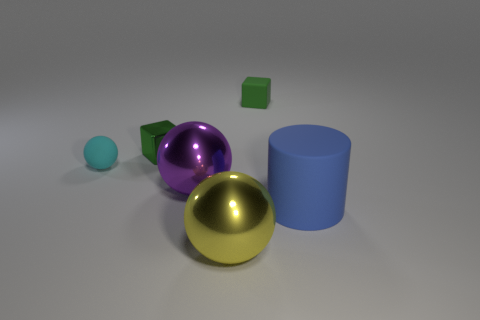Subtract all metal balls. How many balls are left? 1 Subtract all cyan spheres. How many spheres are left? 2 Add 3 cyan metallic cubes. How many objects exist? 9 Subtract all cylinders. How many objects are left? 5 Subtract 1 cylinders. How many cylinders are left? 0 Subtract all blue balls. How many brown cubes are left? 0 Subtract all cyan spheres. Subtract all blue cylinders. How many spheres are left? 2 Subtract all big cyan shiny things. Subtract all yellow spheres. How many objects are left? 5 Add 2 small metallic things. How many small metallic things are left? 3 Add 1 cyan balls. How many cyan balls exist? 2 